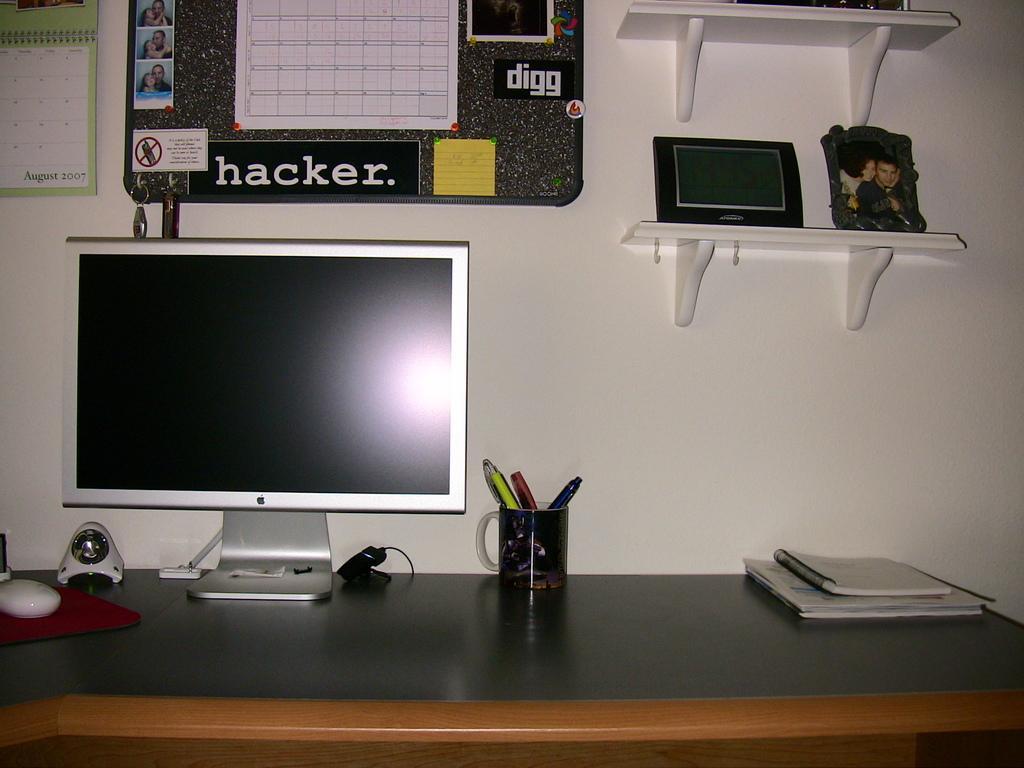Please provide a concise description of this image. In the background we can see board and calendar on the wall. In this picture we can see a frame and objects on the racks. On a table we can see books, monitor, webcam, mouse, mouse pad, cup and objects. We can see keys, caution note, pictures on a board. We can see penguins in a cup holder. 